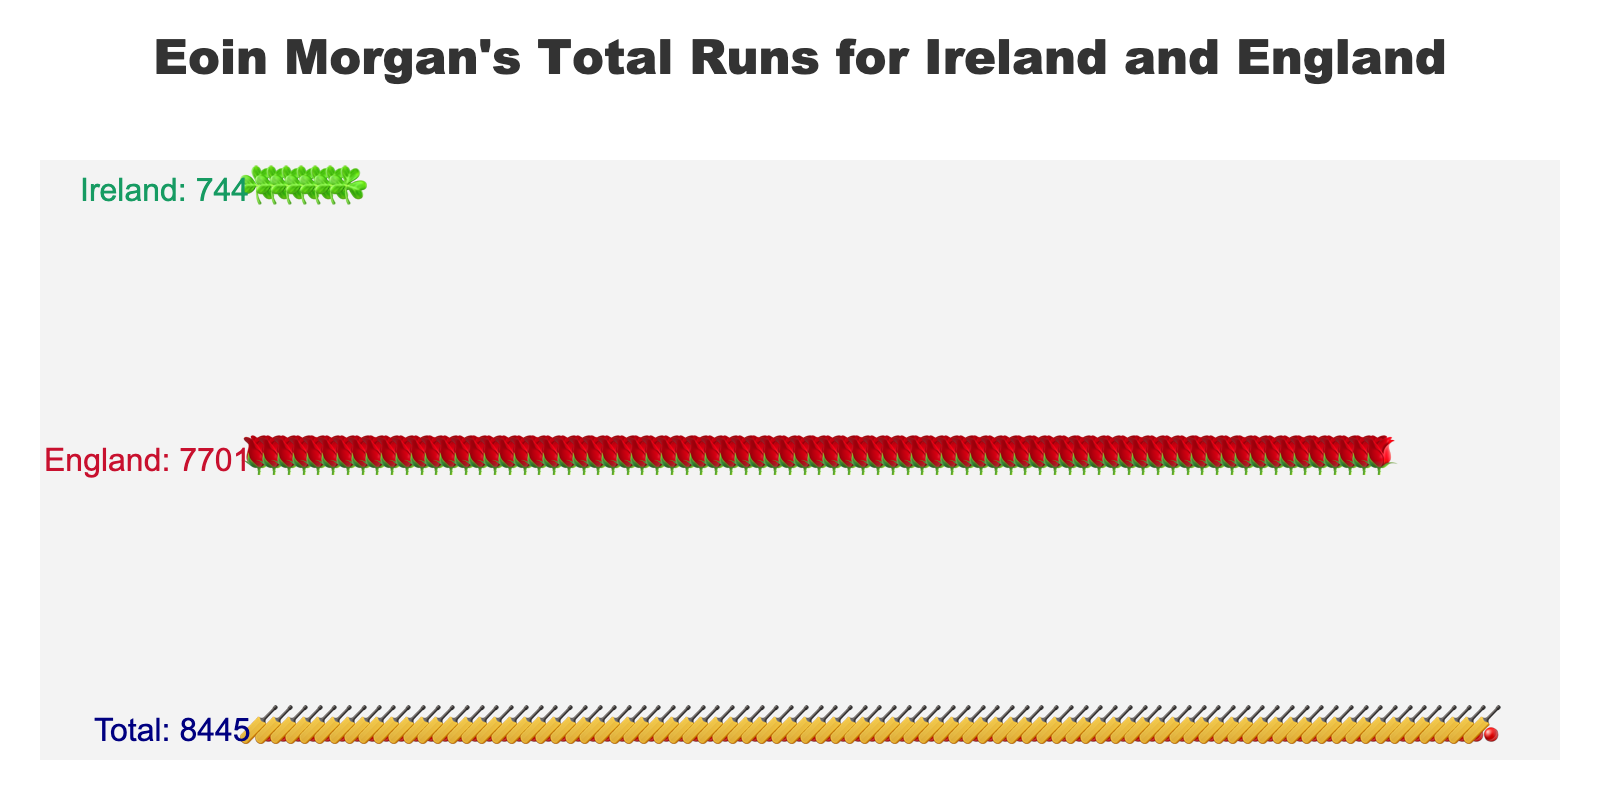What's the title of the figure? The title is found at the top of the figure and usually describes the content of the plot. In this case, it mentions Eoin Morgan's total runs for the two countries.
Answer: Eoin Morgan's Total Runs for Ireland and England What icons are used to represent Ireland and England? The icons representing Ireland and England are shown in the respective sections of the plot. For Ireland, it is a shamrock, and for England, it is a rose.
Answer: Shamrock and rose How many runs did Eoin Morgan score for England? You can find the total runs for England by looking at the annotations or counting the number of rose icons and multiplying by 100. The annotation indicates the exact number.
Answer: 7701 Which country did Eoin Morgan score more runs for? By comparing the number of Ireland and England icons (shamrocks for Ireland and roses for England), you can see which group has more icons. The annotation helps confirm this.
Answer: England What is the total number of runs that Eoin Morgan has scored? The total number of runs is annotated in the "Total" section and represented by cricket bat icons. Summing up the scores for both countries (744 for Ireland and 7701 for England) also gives the total.
Answer: 8445 What is the visual difference between icons representing runs for Ireland and runs for England? The icons for Ireland are shamrocks, and they are green. The icons for England are roses, and they are red. This helps to visually differentiate the contributions.
Answer: Shamrock for Ireland (green) and rose for England (red) How many more runs did Eoin Morgan score for England compared to Ireland? Subtract the total runs for Ireland from the total runs for England (7701 - 744) to find the difference.
Answer: 6957 Which category has the fewest data points, and how can you tell? You can identify the category with the least number of data points by counting the icons for each category. The fewest icons (shamrocks) are for Ireland.
Answer: Ireland How are the values for each category annotated on the plot? The values for each category are shown next to the icons and annotated on the left side of the plot near each row of icons.
Answer: Text annotations next to icons What does each cricket bat icon in the "Total" category represent? Each cricket bat icon in the "Total" category represents 100 runs scored by Eoin Morgan. This total is the summation of runs from Ireland and England.
Answer: 100 runs 